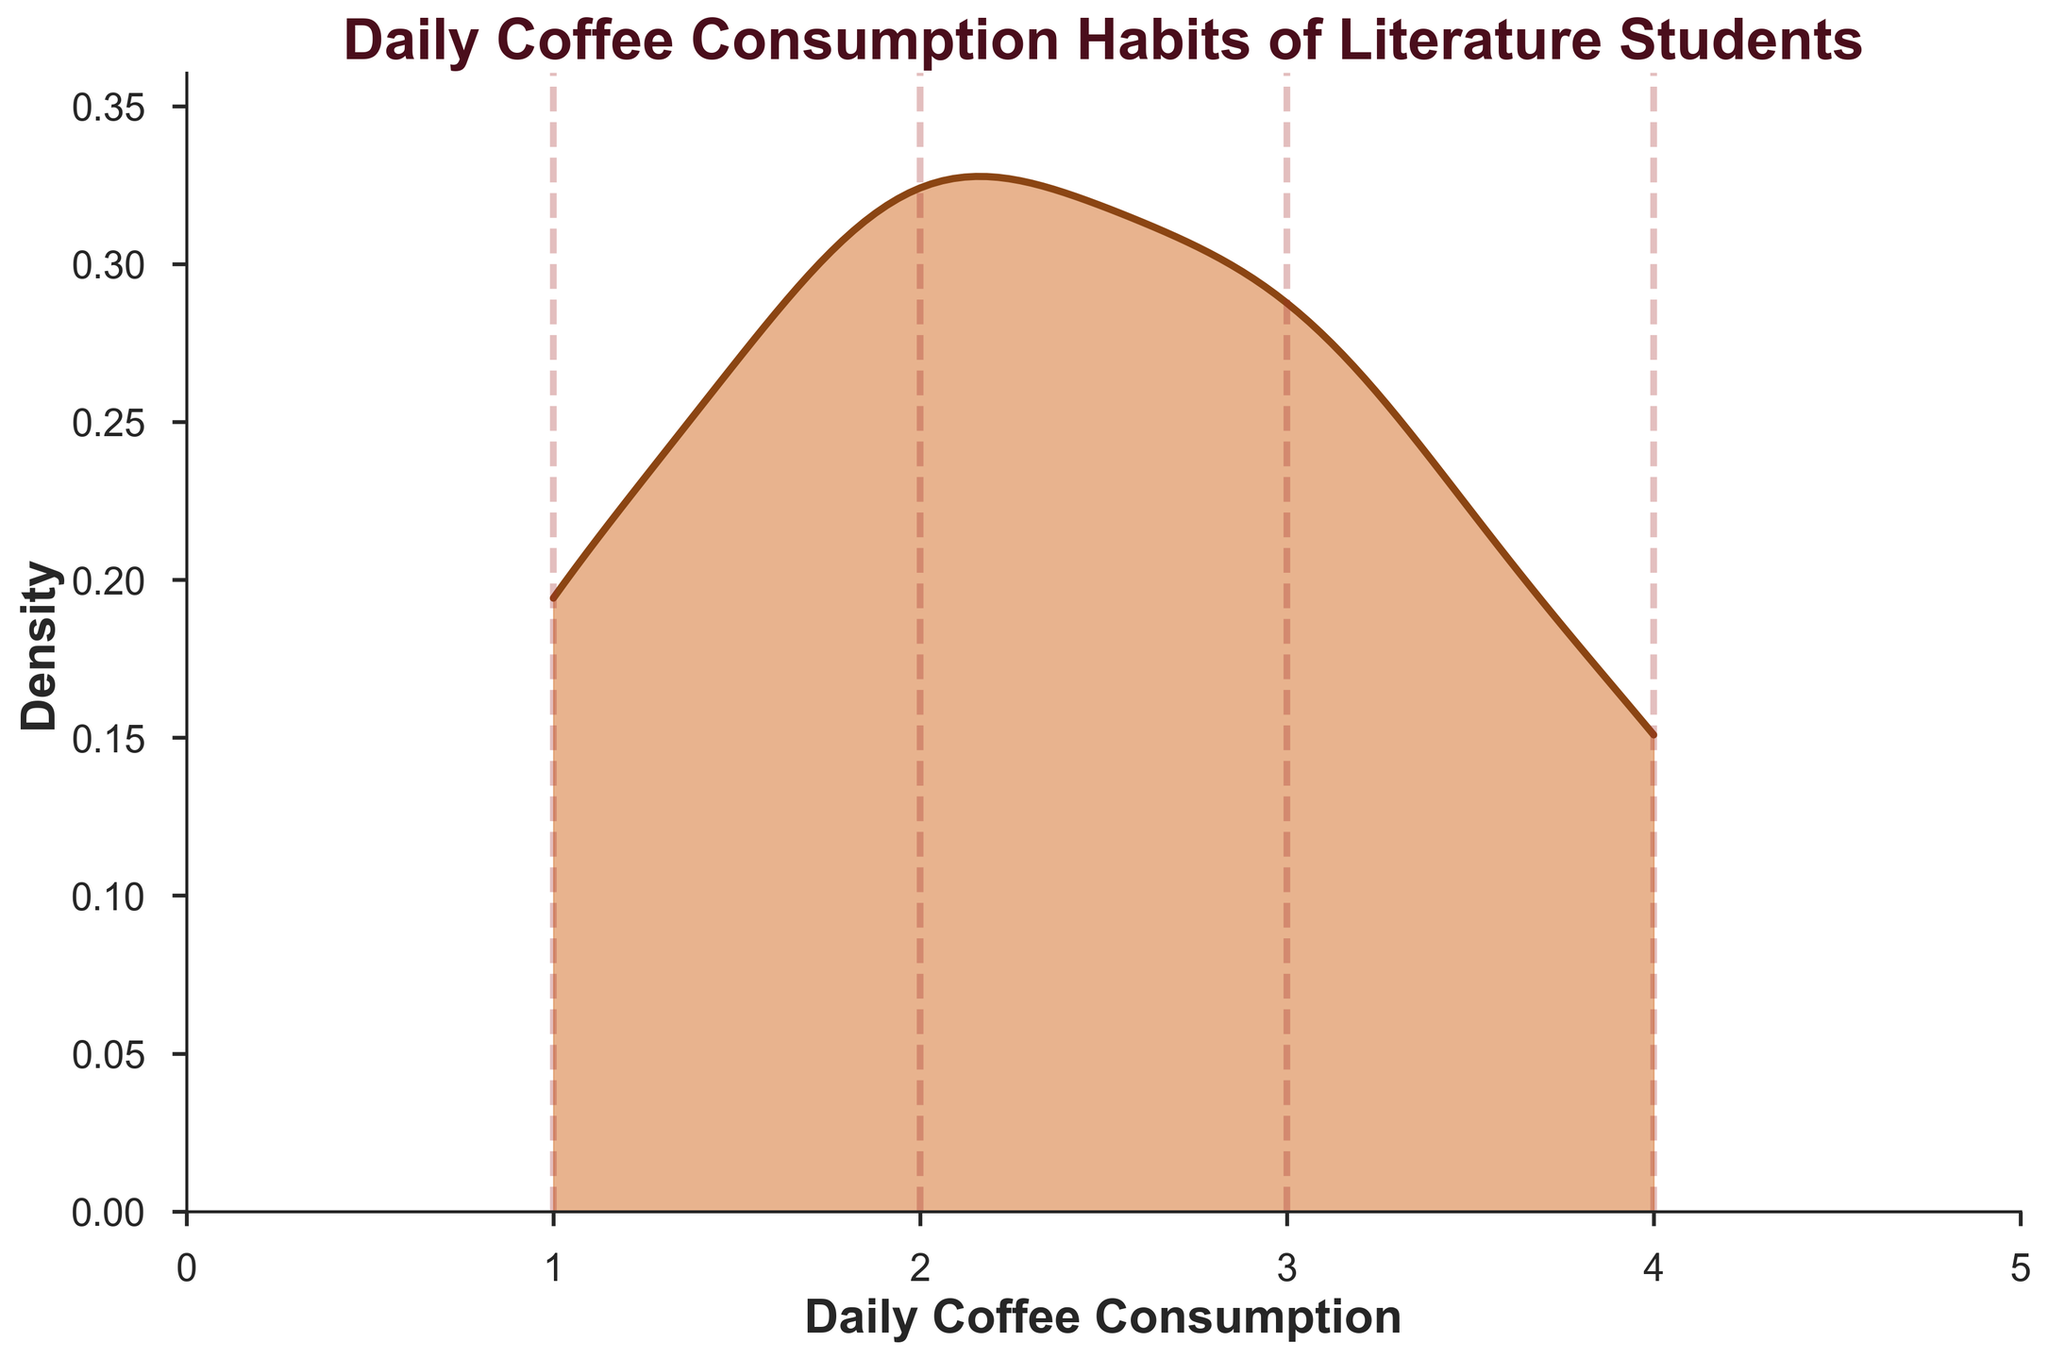What's the title of the plot? The title of the plot is written prominently at the top of the figure.
Answer: Daily Coffee Consumption Habits of Literature Students What are the labels of the x and y axes? The labels of the axes are shown at the bottom and left side of the plot. The x-axis label is "Daily Coffee Consumption," and the y-axis label is "Density."
Answer: Daily Coffee Consumption (x), Density (y) How many vertical dashed lines are there in the plot? Vertical dashed lines appear at intervals corresponding to integer values of daily coffee consumption. By counting them, we can find the number of lines.
Answer: 4 At what value of daily coffee consumption is the peak density observed? To find the peak density, we look for the highest point on the density curve along the x-axis.
Answer: 2 Is there more density to the left or right of the peak density? We compare the area under the density curve to the left and right of the peak density point.
Answer: Right Which value of daily coffee consumption has the lowest density? To find the value with the lowest density, observe where the density curve is closest to the x-axis on either end.
Answer: 1 Compare the density at 1 cup per day with 4 cups per day. Which is higher? By looking at the heights of the density curve at 1 and 4 cups per day, we see which is higher.
Answer: 4 cups/day What's the range of daily coffee consumption values shown in the plot? The range is from the minimum to the maximum value of daily coffee consumption on the x-axis.
Answer: 0 to 5 cups What is the general shape of the density curve? By observing the overall form of the density curve, we describe its shape.
Answer: Bell-shaped 